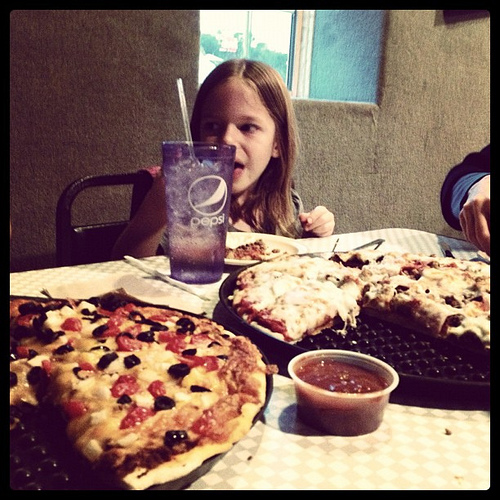Can you describe the setting of the meal? The image shows a casual dining setting with a young girl drinking from a soda glass. There are two pizzas on the table, along with a small bowl that seems to contain extra tomato sauce for dipping. It looks cozy, is it a home or a restaurant? Given the checkered tablecloth, the Pepsi-branded glass, and the style of the plates, it's likely that this is a casual family-style restaurant. 